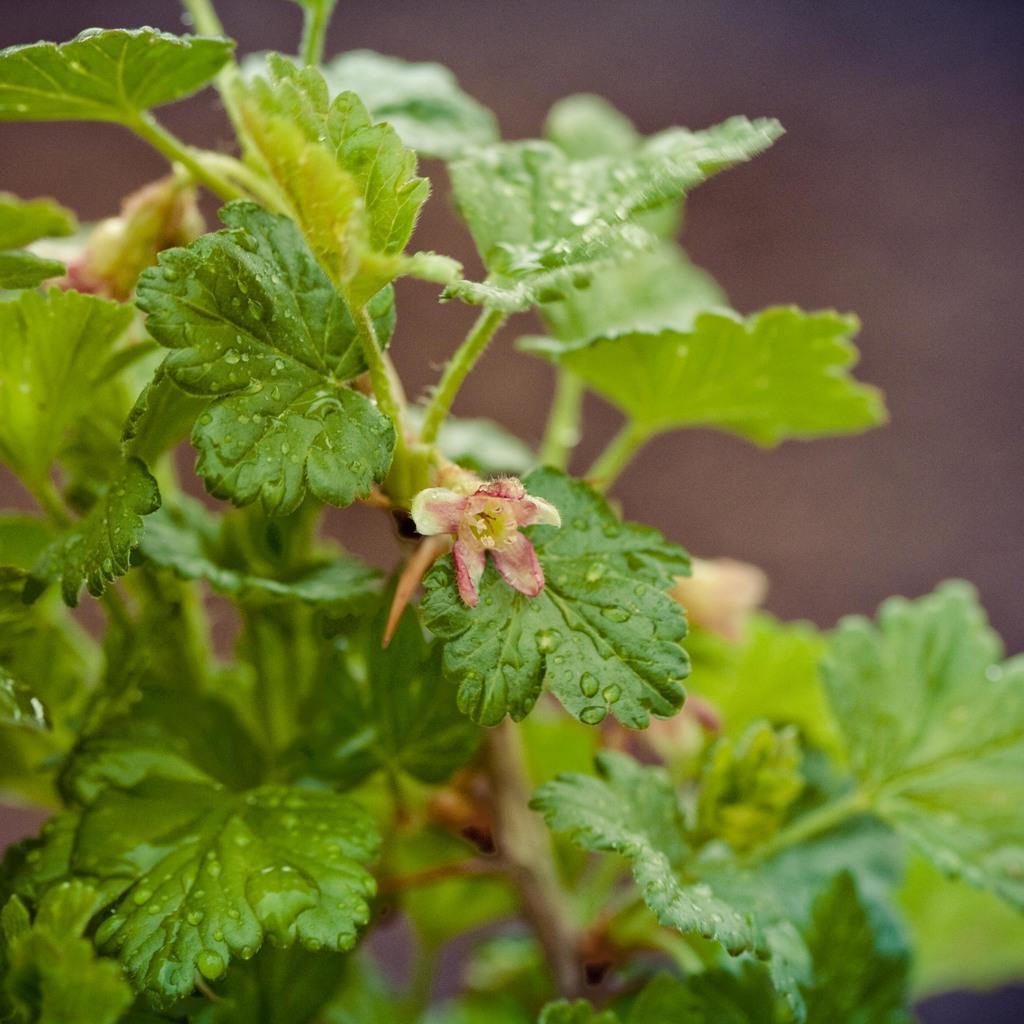In one or two sentences, can you explain what this image depicts? In this picture, we can see a plant with flowers and we can see the background is blurred. 